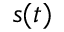Convert formula to latex. <formula><loc_0><loc_0><loc_500><loc_500>s ( t )</formula> 